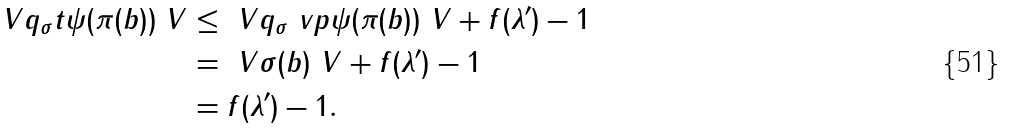<formula> <loc_0><loc_0><loc_500><loc_500>\ V q _ { \sigma } t \psi ( \pi ( b ) ) \ V & \leq \ V q _ { \sigma } \ v p \psi ( \pi ( b ) ) \ V + f ( \lambda ^ { \prime } ) - 1 \\ & = \ V \sigma ( b ) \ V + f ( \lambda ^ { \prime } ) - 1 \\ & = f ( \lambda ^ { \prime } ) - 1 .</formula> 